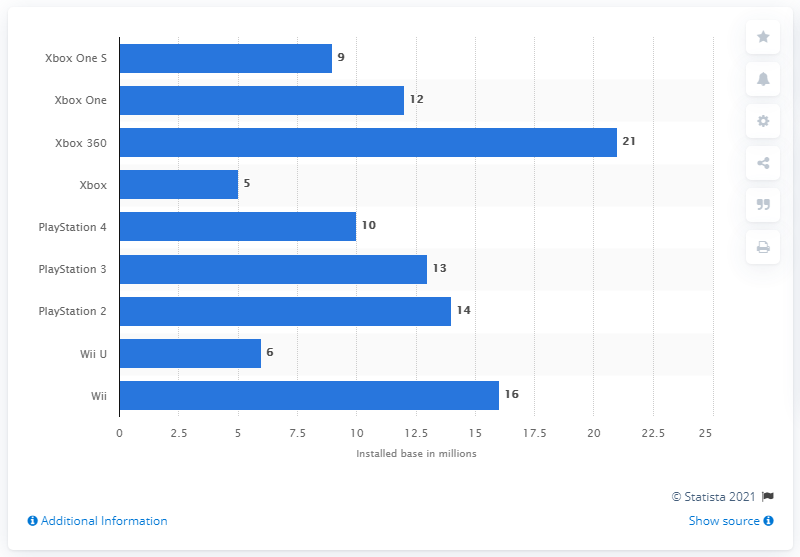Indicate a few pertinent items in this graphic. As of 2017, the installed base of the Xbox 360 was 21 million units. 